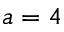<formula> <loc_0><loc_0><loc_500><loc_500>a = 4</formula> 